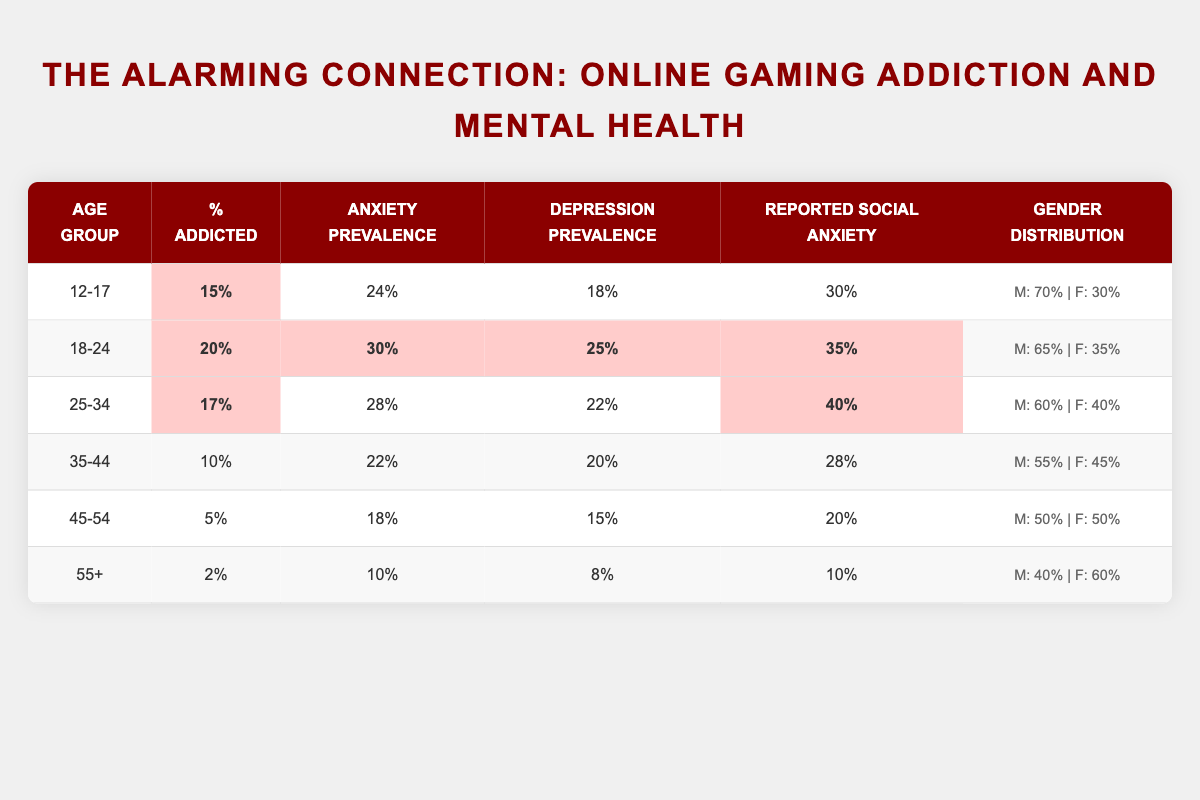What percentage of the 18-24 age group is reported as addicted to online gaming? The table shows that the percentage of the 18-24 age group that is addicted to online gaming is 20%.
Answer: 20% Which age group has the highest reported social anxiety? According to the table, the 25-34 age group has the highest reported social anxiety at 40%.
Answer: 25-34 Is the percentage of addiction lower in the 45-54 age group compared to the 12-17 age group? The 45-54 age group has a percentage addicted of 5%, which is lower than the 12-17 age group at 15%. Therefore, the statement is true.
Answer: Yes What is the average prevalence of anxiety across all age groups? The anxiety prevalence values are 24%, 30%, 28%, 22%, 18%, and 10%. Summing these gives 142%, and dividing by 6 age groups results in an average of 23.67%.
Answer: 23.67% Which age group has a lower percentage of addiction: 35-44 or 25-34? The 35-44 age group's percentage addicted is 10%, while the 25-34 age group is 17%. Thus, 35-44 has the lower percentage.
Answer: 35-44 Do more males than females report online gaming addiction in the 12-17 age group? The gender distribution for 12-17 shows 70% male and 30% female, indicating that more males report addiction.
Answer: Yes What is the percentage difference in the prevalence of depression between the 18-24 and 12-17 age groups? The depression prevalence for 18-24 is 25%, and for 12-17 it is 18%. The difference is 25% - 18% = 7%.
Answer: 7% Is there a correlation between age and the percentage of addiction? By observing the table, younger age groups (12-24) have higher percentages of addiction, while older groups (35+) have lower percentages. This implies a negative correlation.
Answer: Yes How does the depression prevalence change from the 12-17 age group to the 55+ age group? The depression prevalence decreases from 18% in the 12-17 group to 8% in the 55+ group, a drop of 10 percentage points.
Answer: Decrease of 10 percentage points What is the total reported social anxiety prevalence for all age groups combined? Adding reported social anxiety percentages (30%, 35%, 40%, 28%, 20%, 10%) gives 163%. This value does indicate the overall impact across all age groups.
Answer: 163% 